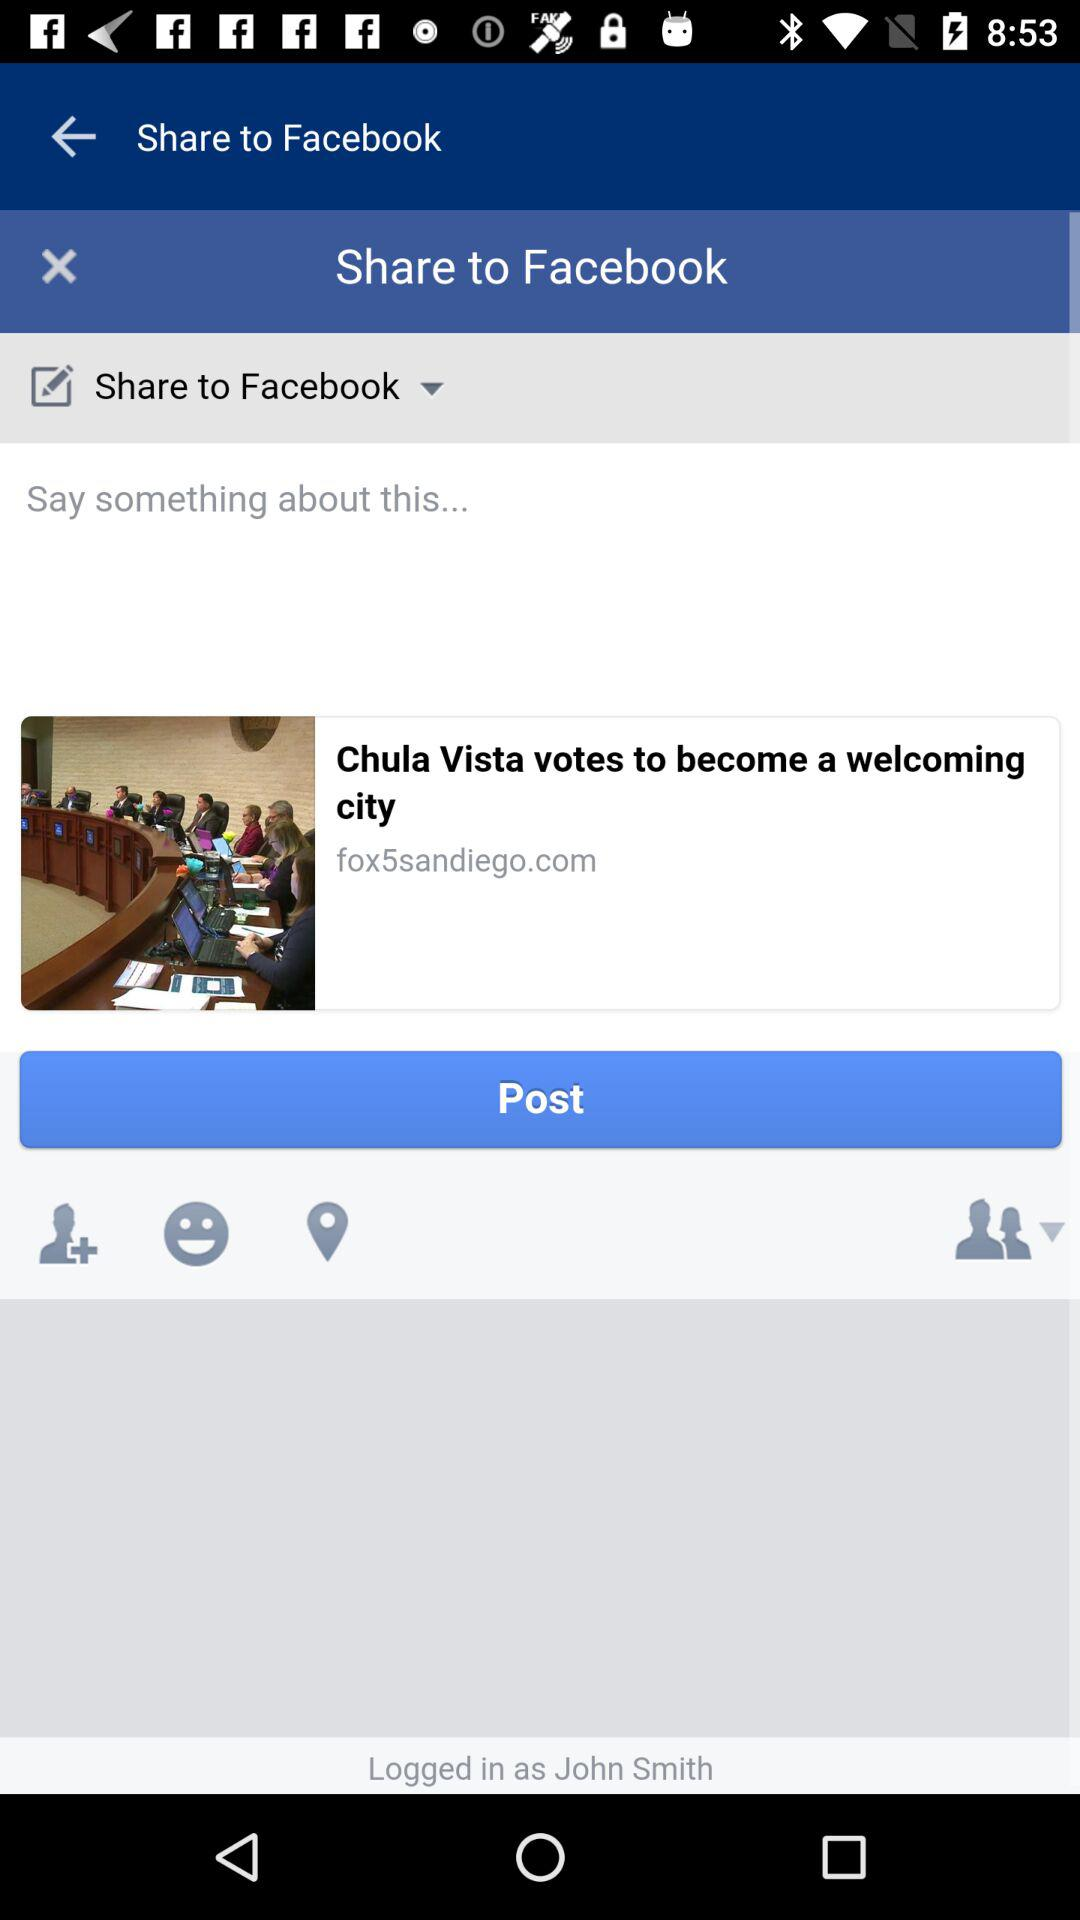What application is being used to share? The application that is being used to share is "Facebook". 